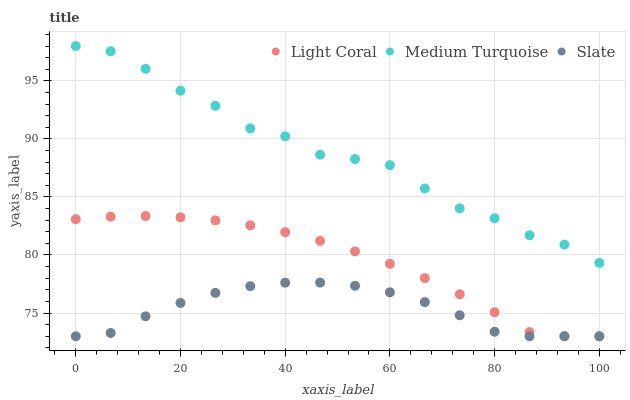Does Slate have the minimum area under the curve?
Answer yes or no. Yes. Does Medium Turquoise have the maximum area under the curve?
Answer yes or no. Yes. Does Medium Turquoise have the minimum area under the curve?
Answer yes or no. No. Does Slate have the maximum area under the curve?
Answer yes or no. No. Is Light Coral the smoothest?
Answer yes or no. Yes. Is Medium Turquoise the roughest?
Answer yes or no. Yes. Is Slate the smoothest?
Answer yes or no. No. Is Slate the roughest?
Answer yes or no. No. Does Light Coral have the lowest value?
Answer yes or no. Yes. Does Medium Turquoise have the lowest value?
Answer yes or no. No. Does Medium Turquoise have the highest value?
Answer yes or no. Yes. Does Slate have the highest value?
Answer yes or no. No. Is Light Coral less than Medium Turquoise?
Answer yes or no. Yes. Is Medium Turquoise greater than Slate?
Answer yes or no. Yes. Does Light Coral intersect Slate?
Answer yes or no. Yes. Is Light Coral less than Slate?
Answer yes or no. No. Is Light Coral greater than Slate?
Answer yes or no. No. Does Light Coral intersect Medium Turquoise?
Answer yes or no. No. 